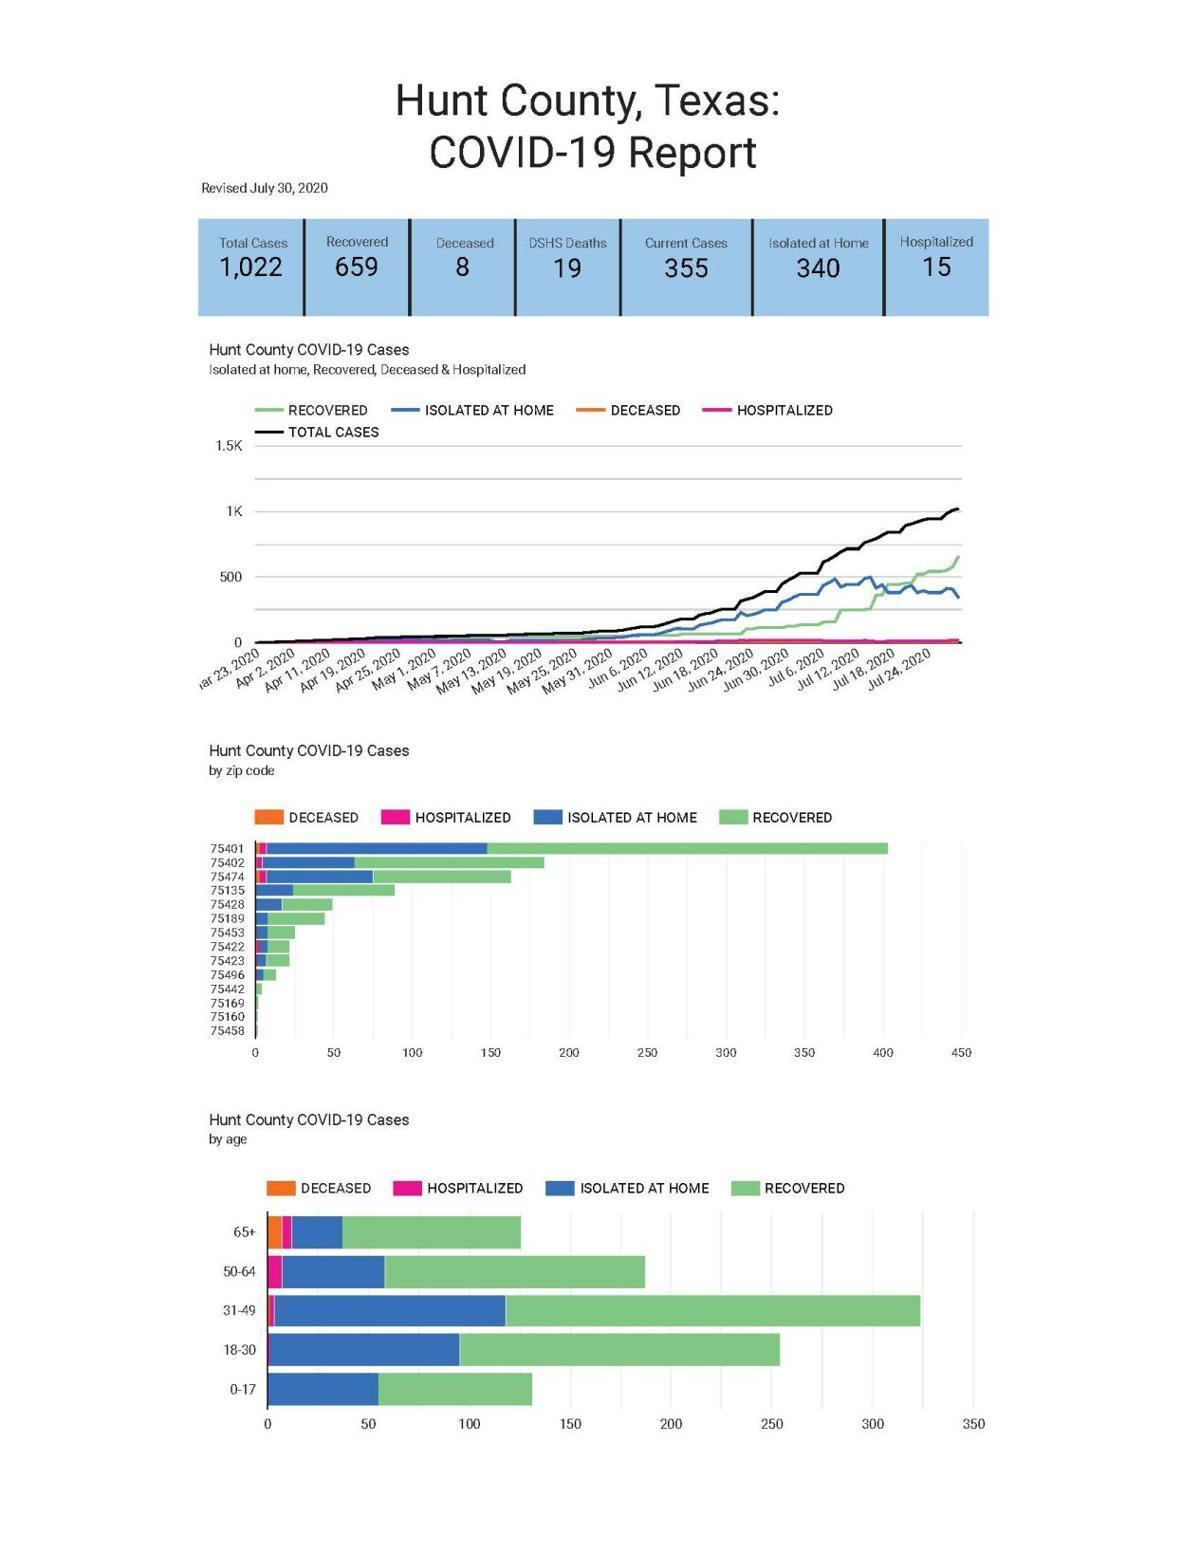What is the difference between total cases and the deceased as of July 30?
Answer the question with a short phrase. 1014 What is the difference between total cases and the current cases as of July 30? 667 What is the difference between total cases and recovered as of July 30? 363 